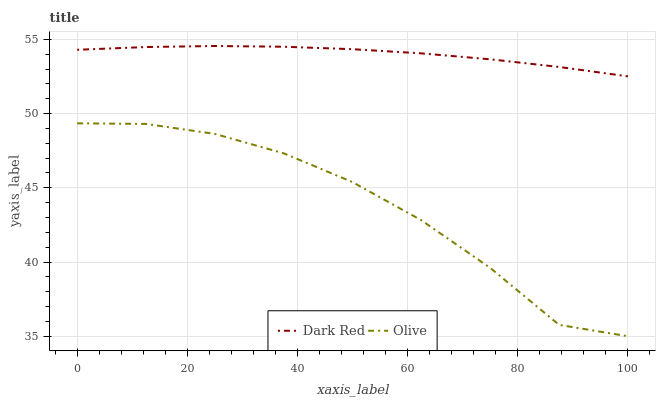Does Olive have the minimum area under the curve?
Answer yes or no. Yes. Does Dark Red have the maximum area under the curve?
Answer yes or no. Yes. Does Dark Red have the minimum area under the curve?
Answer yes or no. No. Is Dark Red the smoothest?
Answer yes or no. Yes. Is Olive the roughest?
Answer yes or no. Yes. Is Dark Red the roughest?
Answer yes or no. No. Does Dark Red have the lowest value?
Answer yes or no. No. Is Olive less than Dark Red?
Answer yes or no. Yes. Is Dark Red greater than Olive?
Answer yes or no. Yes. Does Olive intersect Dark Red?
Answer yes or no. No. 